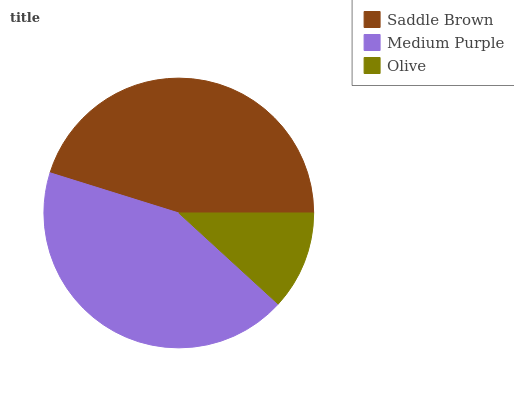Is Olive the minimum?
Answer yes or no. Yes. Is Saddle Brown the maximum?
Answer yes or no. Yes. Is Medium Purple the minimum?
Answer yes or no. No. Is Medium Purple the maximum?
Answer yes or no. No. Is Saddle Brown greater than Medium Purple?
Answer yes or no. Yes. Is Medium Purple less than Saddle Brown?
Answer yes or no. Yes. Is Medium Purple greater than Saddle Brown?
Answer yes or no. No. Is Saddle Brown less than Medium Purple?
Answer yes or no. No. Is Medium Purple the high median?
Answer yes or no. Yes. Is Medium Purple the low median?
Answer yes or no. Yes. Is Saddle Brown the high median?
Answer yes or no. No. Is Saddle Brown the low median?
Answer yes or no. No. 